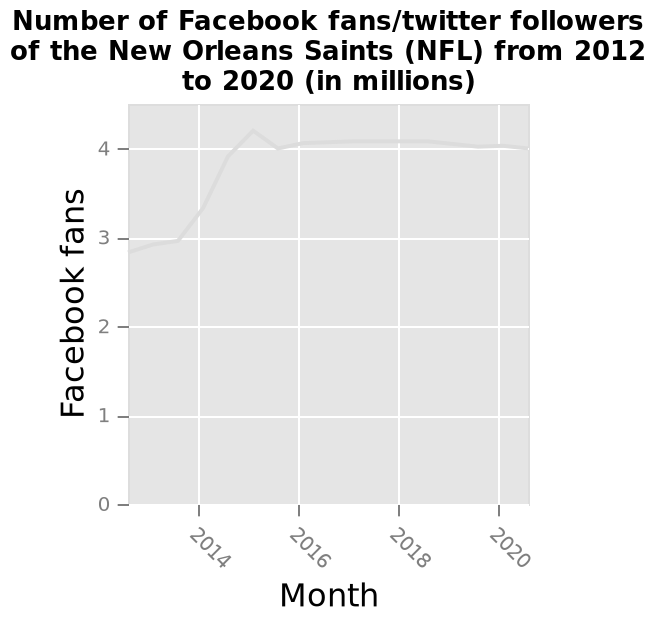<image>
please enumerates aspects of the construction of the chart Here a is a line diagram named Number of Facebook fans/twitter followers of the New Orleans Saints (NFL) from 2012 to 2020 (in millions). The x-axis measures Month along a linear scale of range 2014 to 2020. A linear scale of range 0 to 4 can be seen on the y-axis, marked Facebook fans. 